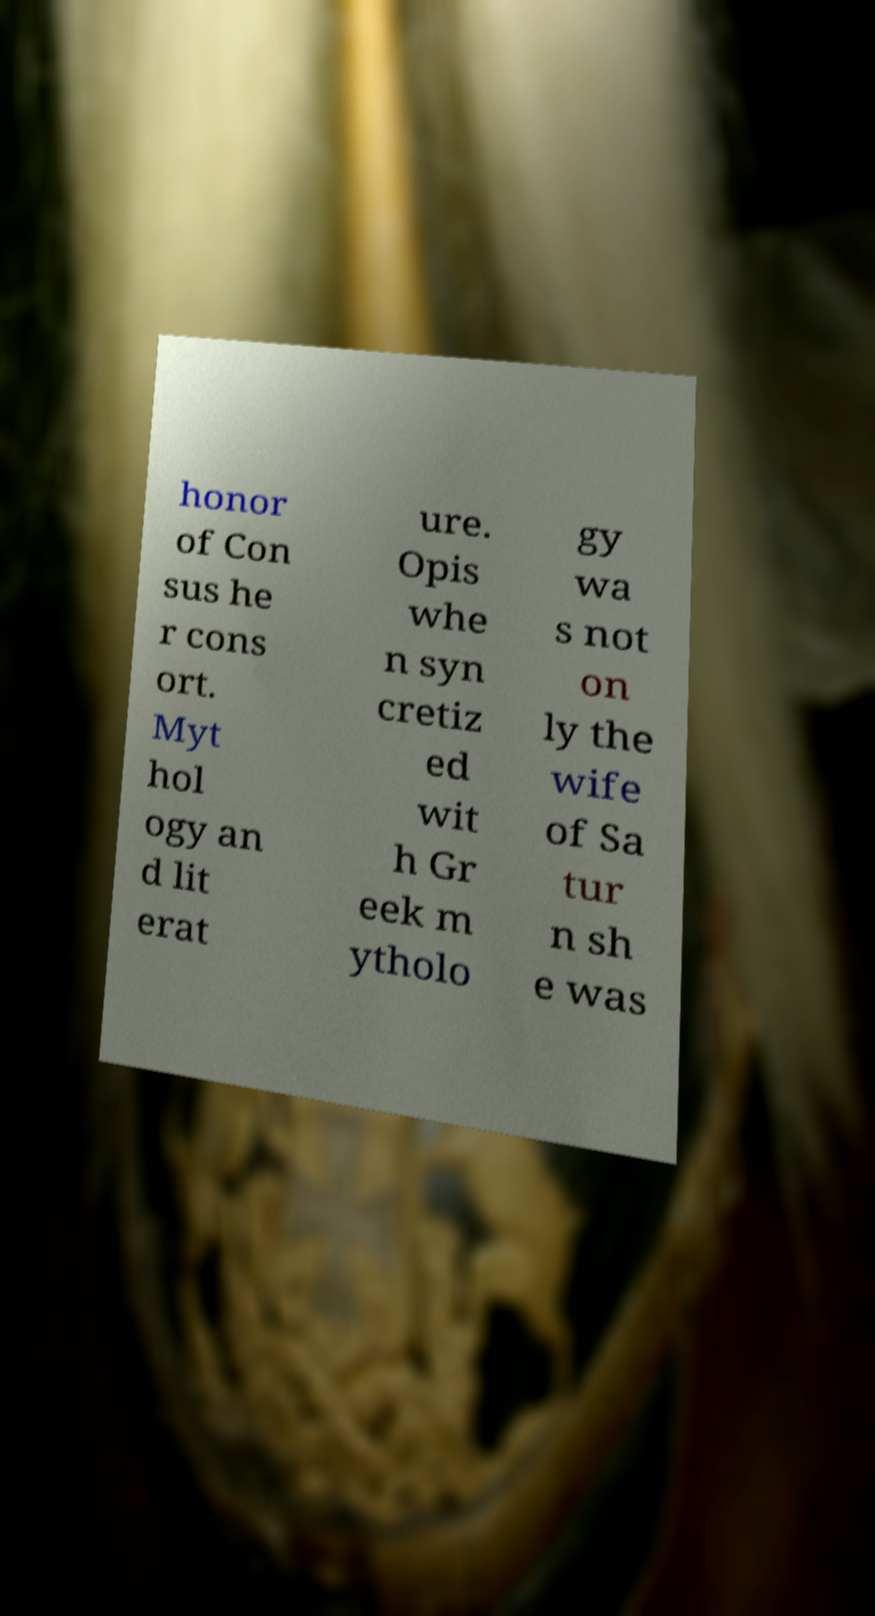I need the written content from this picture converted into text. Can you do that? honor of Con sus he r cons ort. Myt hol ogy an d lit erat ure. Opis whe n syn cretiz ed wit h Gr eek m ytholo gy wa s not on ly the wife of Sa tur n sh e was 